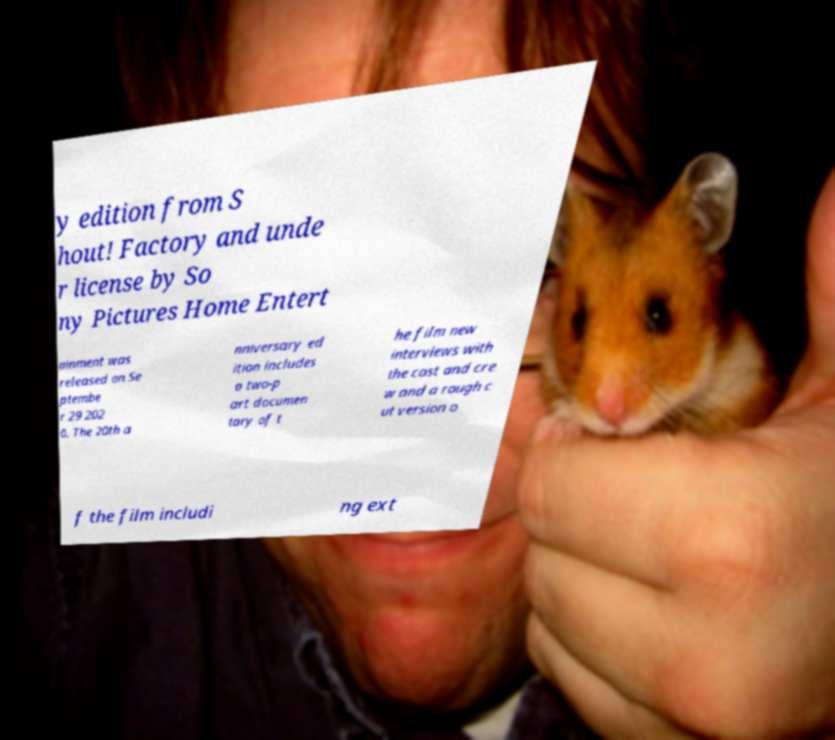Please identify and transcribe the text found in this image. y edition from S hout! Factory and unde r license by So ny Pictures Home Entert ainment was released on Se ptembe r 29 202 0. The 20th a nniversary ed ition includes a two-p art documen tary of t he film new interviews with the cast and cre w and a rough c ut version o f the film includi ng ext 